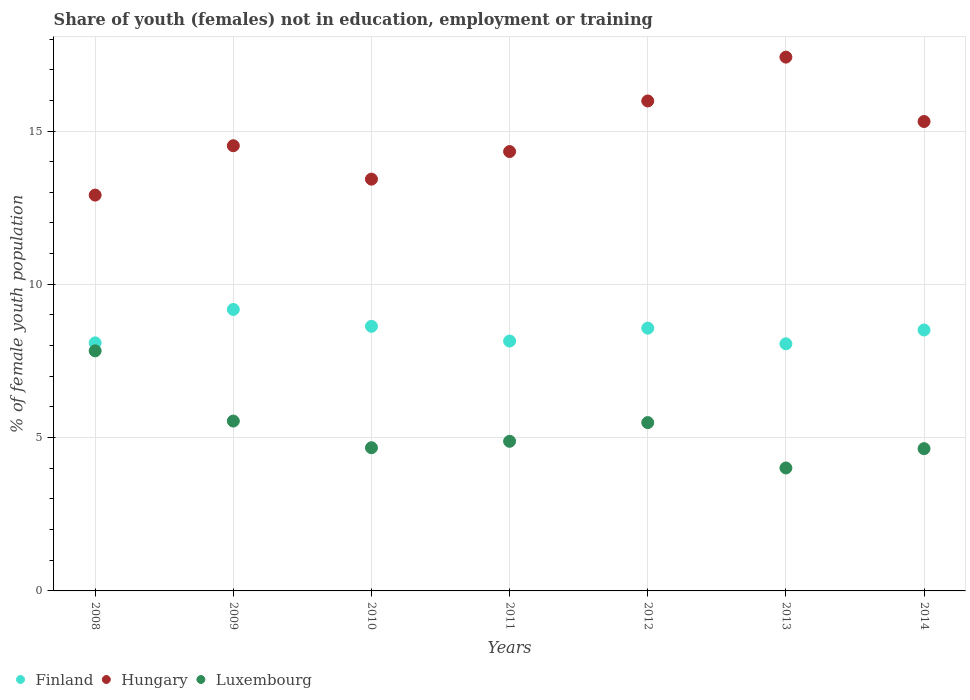How many different coloured dotlines are there?
Give a very brief answer. 3. What is the percentage of unemployed female population in in Finland in 2014?
Give a very brief answer. 8.51. Across all years, what is the maximum percentage of unemployed female population in in Luxembourg?
Your answer should be very brief. 7.83. Across all years, what is the minimum percentage of unemployed female population in in Hungary?
Your answer should be compact. 12.91. What is the total percentage of unemployed female population in in Luxembourg in the graph?
Your answer should be very brief. 37.06. What is the difference between the percentage of unemployed female population in in Luxembourg in 2011 and that in 2014?
Provide a short and direct response. 0.24. What is the difference between the percentage of unemployed female population in in Finland in 2011 and the percentage of unemployed female population in in Luxembourg in 2009?
Ensure brevity in your answer.  2.61. What is the average percentage of unemployed female population in in Hungary per year?
Offer a terse response. 14.84. In the year 2009, what is the difference between the percentage of unemployed female population in in Hungary and percentage of unemployed female population in in Luxembourg?
Keep it short and to the point. 8.98. What is the ratio of the percentage of unemployed female population in in Hungary in 2009 to that in 2013?
Ensure brevity in your answer.  0.83. Is the percentage of unemployed female population in in Finland in 2010 less than that in 2012?
Provide a short and direct response. No. Is the difference between the percentage of unemployed female population in in Hungary in 2010 and 2013 greater than the difference between the percentage of unemployed female population in in Luxembourg in 2010 and 2013?
Keep it short and to the point. No. What is the difference between the highest and the second highest percentage of unemployed female population in in Hungary?
Provide a short and direct response. 1.43. What is the difference between the highest and the lowest percentage of unemployed female population in in Hungary?
Offer a very short reply. 4.5. In how many years, is the percentage of unemployed female population in in Hungary greater than the average percentage of unemployed female population in in Hungary taken over all years?
Provide a succinct answer. 3. Is the sum of the percentage of unemployed female population in in Hungary in 2008 and 2012 greater than the maximum percentage of unemployed female population in in Finland across all years?
Offer a very short reply. Yes. Is it the case that in every year, the sum of the percentage of unemployed female population in in Finland and percentage of unemployed female population in in Luxembourg  is greater than the percentage of unemployed female population in in Hungary?
Offer a very short reply. No. Does the percentage of unemployed female population in in Luxembourg monotonically increase over the years?
Keep it short and to the point. No. Is the percentage of unemployed female population in in Luxembourg strictly less than the percentage of unemployed female population in in Finland over the years?
Your response must be concise. Yes. What is the difference between two consecutive major ticks on the Y-axis?
Provide a short and direct response. 5. Does the graph contain grids?
Give a very brief answer. Yes. Where does the legend appear in the graph?
Offer a terse response. Bottom left. How many legend labels are there?
Keep it short and to the point. 3. How are the legend labels stacked?
Your answer should be very brief. Horizontal. What is the title of the graph?
Offer a terse response. Share of youth (females) not in education, employment or training. What is the label or title of the X-axis?
Ensure brevity in your answer.  Years. What is the label or title of the Y-axis?
Provide a succinct answer. % of female youth population. What is the % of female youth population in Finland in 2008?
Your answer should be compact. 8.09. What is the % of female youth population in Hungary in 2008?
Provide a succinct answer. 12.91. What is the % of female youth population in Luxembourg in 2008?
Give a very brief answer. 7.83. What is the % of female youth population of Finland in 2009?
Keep it short and to the point. 9.18. What is the % of female youth population of Hungary in 2009?
Your response must be concise. 14.52. What is the % of female youth population of Luxembourg in 2009?
Your answer should be compact. 5.54. What is the % of female youth population of Finland in 2010?
Provide a short and direct response. 8.63. What is the % of female youth population in Hungary in 2010?
Make the answer very short. 13.43. What is the % of female youth population of Luxembourg in 2010?
Provide a succinct answer. 4.67. What is the % of female youth population of Finland in 2011?
Provide a short and direct response. 8.15. What is the % of female youth population of Hungary in 2011?
Provide a succinct answer. 14.33. What is the % of female youth population in Luxembourg in 2011?
Provide a succinct answer. 4.88. What is the % of female youth population of Finland in 2012?
Offer a very short reply. 8.57. What is the % of female youth population of Hungary in 2012?
Keep it short and to the point. 15.98. What is the % of female youth population in Luxembourg in 2012?
Provide a short and direct response. 5.49. What is the % of female youth population of Finland in 2013?
Make the answer very short. 8.06. What is the % of female youth population of Hungary in 2013?
Make the answer very short. 17.41. What is the % of female youth population of Luxembourg in 2013?
Ensure brevity in your answer.  4.01. What is the % of female youth population in Finland in 2014?
Your response must be concise. 8.51. What is the % of female youth population of Hungary in 2014?
Provide a succinct answer. 15.31. What is the % of female youth population in Luxembourg in 2014?
Make the answer very short. 4.64. Across all years, what is the maximum % of female youth population in Finland?
Ensure brevity in your answer.  9.18. Across all years, what is the maximum % of female youth population in Hungary?
Ensure brevity in your answer.  17.41. Across all years, what is the maximum % of female youth population of Luxembourg?
Make the answer very short. 7.83. Across all years, what is the minimum % of female youth population in Finland?
Provide a short and direct response. 8.06. Across all years, what is the minimum % of female youth population of Hungary?
Keep it short and to the point. 12.91. Across all years, what is the minimum % of female youth population in Luxembourg?
Your response must be concise. 4.01. What is the total % of female youth population in Finland in the graph?
Offer a terse response. 59.19. What is the total % of female youth population of Hungary in the graph?
Make the answer very short. 103.89. What is the total % of female youth population of Luxembourg in the graph?
Make the answer very short. 37.06. What is the difference between the % of female youth population in Finland in 2008 and that in 2009?
Provide a short and direct response. -1.09. What is the difference between the % of female youth population of Hungary in 2008 and that in 2009?
Your response must be concise. -1.61. What is the difference between the % of female youth population in Luxembourg in 2008 and that in 2009?
Keep it short and to the point. 2.29. What is the difference between the % of female youth population of Finland in 2008 and that in 2010?
Provide a succinct answer. -0.54. What is the difference between the % of female youth population in Hungary in 2008 and that in 2010?
Your response must be concise. -0.52. What is the difference between the % of female youth population of Luxembourg in 2008 and that in 2010?
Offer a terse response. 3.16. What is the difference between the % of female youth population of Finland in 2008 and that in 2011?
Keep it short and to the point. -0.06. What is the difference between the % of female youth population in Hungary in 2008 and that in 2011?
Provide a short and direct response. -1.42. What is the difference between the % of female youth population in Luxembourg in 2008 and that in 2011?
Ensure brevity in your answer.  2.95. What is the difference between the % of female youth population of Finland in 2008 and that in 2012?
Keep it short and to the point. -0.48. What is the difference between the % of female youth population in Hungary in 2008 and that in 2012?
Provide a succinct answer. -3.07. What is the difference between the % of female youth population in Luxembourg in 2008 and that in 2012?
Provide a succinct answer. 2.34. What is the difference between the % of female youth population in Luxembourg in 2008 and that in 2013?
Offer a very short reply. 3.82. What is the difference between the % of female youth population of Finland in 2008 and that in 2014?
Offer a very short reply. -0.42. What is the difference between the % of female youth population in Luxembourg in 2008 and that in 2014?
Provide a short and direct response. 3.19. What is the difference between the % of female youth population of Finland in 2009 and that in 2010?
Ensure brevity in your answer.  0.55. What is the difference between the % of female youth population of Hungary in 2009 and that in 2010?
Your answer should be very brief. 1.09. What is the difference between the % of female youth population of Luxembourg in 2009 and that in 2010?
Make the answer very short. 0.87. What is the difference between the % of female youth population in Finland in 2009 and that in 2011?
Provide a succinct answer. 1.03. What is the difference between the % of female youth population of Hungary in 2009 and that in 2011?
Keep it short and to the point. 0.19. What is the difference between the % of female youth population of Luxembourg in 2009 and that in 2011?
Ensure brevity in your answer.  0.66. What is the difference between the % of female youth population of Finland in 2009 and that in 2012?
Your answer should be very brief. 0.61. What is the difference between the % of female youth population of Hungary in 2009 and that in 2012?
Your answer should be very brief. -1.46. What is the difference between the % of female youth population in Finland in 2009 and that in 2013?
Offer a terse response. 1.12. What is the difference between the % of female youth population in Hungary in 2009 and that in 2013?
Your response must be concise. -2.89. What is the difference between the % of female youth population of Luxembourg in 2009 and that in 2013?
Keep it short and to the point. 1.53. What is the difference between the % of female youth population of Finland in 2009 and that in 2014?
Your response must be concise. 0.67. What is the difference between the % of female youth population of Hungary in 2009 and that in 2014?
Keep it short and to the point. -0.79. What is the difference between the % of female youth population of Finland in 2010 and that in 2011?
Make the answer very short. 0.48. What is the difference between the % of female youth population in Luxembourg in 2010 and that in 2011?
Offer a very short reply. -0.21. What is the difference between the % of female youth population of Finland in 2010 and that in 2012?
Your answer should be compact. 0.06. What is the difference between the % of female youth population in Hungary in 2010 and that in 2012?
Give a very brief answer. -2.55. What is the difference between the % of female youth population of Luxembourg in 2010 and that in 2012?
Offer a very short reply. -0.82. What is the difference between the % of female youth population of Finland in 2010 and that in 2013?
Provide a succinct answer. 0.57. What is the difference between the % of female youth population of Hungary in 2010 and that in 2013?
Your answer should be compact. -3.98. What is the difference between the % of female youth population in Luxembourg in 2010 and that in 2013?
Your response must be concise. 0.66. What is the difference between the % of female youth population in Finland in 2010 and that in 2014?
Offer a very short reply. 0.12. What is the difference between the % of female youth population in Hungary in 2010 and that in 2014?
Provide a short and direct response. -1.88. What is the difference between the % of female youth population in Luxembourg in 2010 and that in 2014?
Offer a very short reply. 0.03. What is the difference between the % of female youth population of Finland in 2011 and that in 2012?
Your response must be concise. -0.42. What is the difference between the % of female youth population of Hungary in 2011 and that in 2012?
Offer a very short reply. -1.65. What is the difference between the % of female youth population of Luxembourg in 2011 and that in 2012?
Make the answer very short. -0.61. What is the difference between the % of female youth population of Finland in 2011 and that in 2013?
Offer a terse response. 0.09. What is the difference between the % of female youth population in Hungary in 2011 and that in 2013?
Offer a terse response. -3.08. What is the difference between the % of female youth population in Luxembourg in 2011 and that in 2013?
Give a very brief answer. 0.87. What is the difference between the % of female youth population in Finland in 2011 and that in 2014?
Ensure brevity in your answer.  -0.36. What is the difference between the % of female youth population in Hungary in 2011 and that in 2014?
Provide a short and direct response. -0.98. What is the difference between the % of female youth population in Luxembourg in 2011 and that in 2014?
Make the answer very short. 0.24. What is the difference between the % of female youth population of Finland in 2012 and that in 2013?
Offer a terse response. 0.51. What is the difference between the % of female youth population in Hungary in 2012 and that in 2013?
Offer a very short reply. -1.43. What is the difference between the % of female youth population of Luxembourg in 2012 and that in 2013?
Provide a succinct answer. 1.48. What is the difference between the % of female youth population in Finland in 2012 and that in 2014?
Your response must be concise. 0.06. What is the difference between the % of female youth population of Hungary in 2012 and that in 2014?
Your answer should be very brief. 0.67. What is the difference between the % of female youth population in Finland in 2013 and that in 2014?
Your response must be concise. -0.45. What is the difference between the % of female youth population in Hungary in 2013 and that in 2014?
Provide a succinct answer. 2.1. What is the difference between the % of female youth population in Luxembourg in 2013 and that in 2014?
Make the answer very short. -0.63. What is the difference between the % of female youth population in Finland in 2008 and the % of female youth population in Hungary in 2009?
Provide a short and direct response. -6.43. What is the difference between the % of female youth population of Finland in 2008 and the % of female youth population of Luxembourg in 2009?
Offer a very short reply. 2.55. What is the difference between the % of female youth population of Hungary in 2008 and the % of female youth population of Luxembourg in 2009?
Provide a short and direct response. 7.37. What is the difference between the % of female youth population in Finland in 2008 and the % of female youth population in Hungary in 2010?
Make the answer very short. -5.34. What is the difference between the % of female youth population of Finland in 2008 and the % of female youth population of Luxembourg in 2010?
Make the answer very short. 3.42. What is the difference between the % of female youth population in Hungary in 2008 and the % of female youth population in Luxembourg in 2010?
Give a very brief answer. 8.24. What is the difference between the % of female youth population of Finland in 2008 and the % of female youth population of Hungary in 2011?
Provide a succinct answer. -6.24. What is the difference between the % of female youth population of Finland in 2008 and the % of female youth population of Luxembourg in 2011?
Your answer should be compact. 3.21. What is the difference between the % of female youth population of Hungary in 2008 and the % of female youth population of Luxembourg in 2011?
Offer a very short reply. 8.03. What is the difference between the % of female youth population in Finland in 2008 and the % of female youth population in Hungary in 2012?
Offer a terse response. -7.89. What is the difference between the % of female youth population of Hungary in 2008 and the % of female youth population of Luxembourg in 2012?
Your response must be concise. 7.42. What is the difference between the % of female youth population in Finland in 2008 and the % of female youth population in Hungary in 2013?
Your answer should be very brief. -9.32. What is the difference between the % of female youth population of Finland in 2008 and the % of female youth population of Luxembourg in 2013?
Provide a succinct answer. 4.08. What is the difference between the % of female youth population in Finland in 2008 and the % of female youth population in Hungary in 2014?
Provide a succinct answer. -7.22. What is the difference between the % of female youth population in Finland in 2008 and the % of female youth population in Luxembourg in 2014?
Keep it short and to the point. 3.45. What is the difference between the % of female youth population in Hungary in 2008 and the % of female youth population in Luxembourg in 2014?
Give a very brief answer. 8.27. What is the difference between the % of female youth population of Finland in 2009 and the % of female youth population of Hungary in 2010?
Make the answer very short. -4.25. What is the difference between the % of female youth population of Finland in 2009 and the % of female youth population of Luxembourg in 2010?
Offer a very short reply. 4.51. What is the difference between the % of female youth population of Hungary in 2009 and the % of female youth population of Luxembourg in 2010?
Ensure brevity in your answer.  9.85. What is the difference between the % of female youth population of Finland in 2009 and the % of female youth population of Hungary in 2011?
Your answer should be very brief. -5.15. What is the difference between the % of female youth population in Finland in 2009 and the % of female youth population in Luxembourg in 2011?
Keep it short and to the point. 4.3. What is the difference between the % of female youth population of Hungary in 2009 and the % of female youth population of Luxembourg in 2011?
Provide a succinct answer. 9.64. What is the difference between the % of female youth population of Finland in 2009 and the % of female youth population of Hungary in 2012?
Provide a short and direct response. -6.8. What is the difference between the % of female youth population in Finland in 2009 and the % of female youth population in Luxembourg in 2012?
Your answer should be compact. 3.69. What is the difference between the % of female youth population of Hungary in 2009 and the % of female youth population of Luxembourg in 2012?
Offer a terse response. 9.03. What is the difference between the % of female youth population in Finland in 2009 and the % of female youth population in Hungary in 2013?
Your answer should be very brief. -8.23. What is the difference between the % of female youth population of Finland in 2009 and the % of female youth population of Luxembourg in 2013?
Your answer should be very brief. 5.17. What is the difference between the % of female youth population in Hungary in 2009 and the % of female youth population in Luxembourg in 2013?
Offer a terse response. 10.51. What is the difference between the % of female youth population in Finland in 2009 and the % of female youth population in Hungary in 2014?
Your response must be concise. -6.13. What is the difference between the % of female youth population of Finland in 2009 and the % of female youth population of Luxembourg in 2014?
Offer a very short reply. 4.54. What is the difference between the % of female youth population in Hungary in 2009 and the % of female youth population in Luxembourg in 2014?
Make the answer very short. 9.88. What is the difference between the % of female youth population of Finland in 2010 and the % of female youth population of Hungary in 2011?
Give a very brief answer. -5.7. What is the difference between the % of female youth population in Finland in 2010 and the % of female youth population in Luxembourg in 2011?
Offer a very short reply. 3.75. What is the difference between the % of female youth population in Hungary in 2010 and the % of female youth population in Luxembourg in 2011?
Ensure brevity in your answer.  8.55. What is the difference between the % of female youth population in Finland in 2010 and the % of female youth population in Hungary in 2012?
Keep it short and to the point. -7.35. What is the difference between the % of female youth population of Finland in 2010 and the % of female youth population of Luxembourg in 2012?
Your response must be concise. 3.14. What is the difference between the % of female youth population in Hungary in 2010 and the % of female youth population in Luxembourg in 2012?
Your answer should be compact. 7.94. What is the difference between the % of female youth population of Finland in 2010 and the % of female youth population of Hungary in 2013?
Your response must be concise. -8.78. What is the difference between the % of female youth population in Finland in 2010 and the % of female youth population in Luxembourg in 2013?
Give a very brief answer. 4.62. What is the difference between the % of female youth population in Hungary in 2010 and the % of female youth population in Luxembourg in 2013?
Provide a short and direct response. 9.42. What is the difference between the % of female youth population in Finland in 2010 and the % of female youth population in Hungary in 2014?
Your answer should be very brief. -6.68. What is the difference between the % of female youth population in Finland in 2010 and the % of female youth population in Luxembourg in 2014?
Offer a very short reply. 3.99. What is the difference between the % of female youth population in Hungary in 2010 and the % of female youth population in Luxembourg in 2014?
Provide a succinct answer. 8.79. What is the difference between the % of female youth population of Finland in 2011 and the % of female youth population of Hungary in 2012?
Give a very brief answer. -7.83. What is the difference between the % of female youth population of Finland in 2011 and the % of female youth population of Luxembourg in 2012?
Provide a short and direct response. 2.66. What is the difference between the % of female youth population of Hungary in 2011 and the % of female youth population of Luxembourg in 2012?
Give a very brief answer. 8.84. What is the difference between the % of female youth population in Finland in 2011 and the % of female youth population in Hungary in 2013?
Provide a succinct answer. -9.26. What is the difference between the % of female youth population in Finland in 2011 and the % of female youth population in Luxembourg in 2013?
Your answer should be compact. 4.14. What is the difference between the % of female youth population of Hungary in 2011 and the % of female youth population of Luxembourg in 2013?
Ensure brevity in your answer.  10.32. What is the difference between the % of female youth population of Finland in 2011 and the % of female youth population of Hungary in 2014?
Offer a terse response. -7.16. What is the difference between the % of female youth population of Finland in 2011 and the % of female youth population of Luxembourg in 2014?
Give a very brief answer. 3.51. What is the difference between the % of female youth population in Hungary in 2011 and the % of female youth population in Luxembourg in 2014?
Your response must be concise. 9.69. What is the difference between the % of female youth population of Finland in 2012 and the % of female youth population of Hungary in 2013?
Give a very brief answer. -8.84. What is the difference between the % of female youth population in Finland in 2012 and the % of female youth population in Luxembourg in 2013?
Offer a very short reply. 4.56. What is the difference between the % of female youth population in Hungary in 2012 and the % of female youth population in Luxembourg in 2013?
Your response must be concise. 11.97. What is the difference between the % of female youth population in Finland in 2012 and the % of female youth population in Hungary in 2014?
Offer a very short reply. -6.74. What is the difference between the % of female youth population of Finland in 2012 and the % of female youth population of Luxembourg in 2014?
Make the answer very short. 3.93. What is the difference between the % of female youth population in Hungary in 2012 and the % of female youth population in Luxembourg in 2014?
Ensure brevity in your answer.  11.34. What is the difference between the % of female youth population of Finland in 2013 and the % of female youth population of Hungary in 2014?
Your response must be concise. -7.25. What is the difference between the % of female youth population of Finland in 2013 and the % of female youth population of Luxembourg in 2014?
Your response must be concise. 3.42. What is the difference between the % of female youth population of Hungary in 2013 and the % of female youth population of Luxembourg in 2014?
Your answer should be very brief. 12.77. What is the average % of female youth population in Finland per year?
Make the answer very short. 8.46. What is the average % of female youth population of Hungary per year?
Your answer should be compact. 14.84. What is the average % of female youth population of Luxembourg per year?
Ensure brevity in your answer.  5.29. In the year 2008, what is the difference between the % of female youth population in Finland and % of female youth population in Hungary?
Ensure brevity in your answer.  -4.82. In the year 2008, what is the difference between the % of female youth population in Finland and % of female youth population in Luxembourg?
Your answer should be very brief. 0.26. In the year 2008, what is the difference between the % of female youth population in Hungary and % of female youth population in Luxembourg?
Provide a short and direct response. 5.08. In the year 2009, what is the difference between the % of female youth population of Finland and % of female youth population of Hungary?
Your answer should be very brief. -5.34. In the year 2009, what is the difference between the % of female youth population in Finland and % of female youth population in Luxembourg?
Offer a terse response. 3.64. In the year 2009, what is the difference between the % of female youth population of Hungary and % of female youth population of Luxembourg?
Your answer should be compact. 8.98. In the year 2010, what is the difference between the % of female youth population of Finland and % of female youth population of Luxembourg?
Keep it short and to the point. 3.96. In the year 2010, what is the difference between the % of female youth population of Hungary and % of female youth population of Luxembourg?
Offer a very short reply. 8.76. In the year 2011, what is the difference between the % of female youth population in Finland and % of female youth population in Hungary?
Your answer should be very brief. -6.18. In the year 2011, what is the difference between the % of female youth population of Finland and % of female youth population of Luxembourg?
Offer a very short reply. 3.27. In the year 2011, what is the difference between the % of female youth population of Hungary and % of female youth population of Luxembourg?
Keep it short and to the point. 9.45. In the year 2012, what is the difference between the % of female youth population of Finland and % of female youth population of Hungary?
Provide a succinct answer. -7.41. In the year 2012, what is the difference between the % of female youth population of Finland and % of female youth population of Luxembourg?
Give a very brief answer. 3.08. In the year 2012, what is the difference between the % of female youth population of Hungary and % of female youth population of Luxembourg?
Provide a short and direct response. 10.49. In the year 2013, what is the difference between the % of female youth population in Finland and % of female youth population in Hungary?
Ensure brevity in your answer.  -9.35. In the year 2013, what is the difference between the % of female youth population of Finland and % of female youth population of Luxembourg?
Offer a very short reply. 4.05. In the year 2013, what is the difference between the % of female youth population of Hungary and % of female youth population of Luxembourg?
Your answer should be very brief. 13.4. In the year 2014, what is the difference between the % of female youth population in Finland and % of female youth population in Luxembourg?
Provide a succinct answer. 3.87. In the year 2014, what is the difference between the % of female youth population in Hungary and % of female youth population in Luxembourg?
Provide a succinct answer. 10.67. What is the ratio of the % of female youth population of Finland in 2008 to that in 2009?
Make the answer very short. 0.88. What is the ratio of the % of female youth population of Hungary in 2008 to that in 2009?
Offer a terse response. 0.89. What is the ratio of the % of female youth population in Luxembourg in 2008 to that in 2009?
Ensure brevity in your answer.  1.41. What is the ratio of the % of female youth population of Finland in 2008 to that in 2010?
Your answer should be very brief. 0.94. What is the ratio of the % of female youth population in Hungary in 2008 to that in 2010?
Your answer should be very brief. 0.96. What is the ratio of the % of female youth population of Luxembourg in 2008 to that in 2010?
Your answer should be very brief. 1.68. What is the ratio of the % of female youth population in Finland in 2008 to that in 2011?
Your answer should be very brief. 0.99. What is the ratio of the % of female youth population in Hungary in 2008 to that in 2011?
Provide a short and direct response. 0.9. What is the ratio of the % of female youth population in Luxembourg in 2008 to that in 2011?
Keep it short and to the point. 1.6. What is the ratio of the % of female youth population of Finland in 2008 to that in 2012?
Provide a short and direct response. 0.94. What is the ratio of the % of female youth population of Hungary in 2008 to that in 2012?
Your answer should be compact. 0.81. What is the ratio of the % of female youth population of Luxembourg in 2008 to that in 2012?
Provide a succinct answer. 1.43. What is the ratio of the % of female youth population in Hungary in 2008 to that in 2013?
Provide a succinct answer. 0.74. What is the ratio of the % of female youth population of Luxembourg in 2008 to that in 2013?
Your response must be concise. 1.95. What is the ratio of the % of female youth population of Finland in 2008 to that in 2014?
Ensure brevity in your answer.  0.95. What is the ratio of the % of female youth population of Hungary in 2008 to that in 2014?
Provide a short and direct response. 0.84. What is the ratio of the % of female youth population in Luxembourg in 2008 to that in 2014?
Give a very brief answer. 1.69. What is the ratio of the % of female youth population of Finland in 2009 to that in 2010?
Make the answer very short. 1.06. What is the ratio of the % of female youth population in Hungary in 2009 to that in 2010?
Give a very brief answer. 1.08. What is the ratio of the % of female youth population of Luxembourg in 2009 to that in 2010?
Ensure brevity in your answer.  1.19. What is the ratio of the % of female youth population of Finland in 2009 to that in 2011?
Make the answer very short. 1.13. What is the ratio of the % of female youth population in Hungary in 2009 to that in 2011?
Keep it short and to the point. 1.01. What is the ratio of the % of female youth population of Luxembourg in 2009 to that in 2011?
Provide a short and direct response. 1.14. What is the ratio of the % of female youth population of Finland in 2009 to that in 2012?
Ensure brevity in your answer.  1.07. What is the ratio of the % of female youth population of Hungary in 2009 to that in 2012?
Ensure brevity in your answer.  0.91. What is the ratio of the % of female youth population in Luxembourg in 2009 to that in 2012?
Provide a succinct answer. 1.01. What is the ratio of the % of female youth population of Finland in 2009 to that in 2013?
Your answer should be very brief. 1.14. What is the ratio of the % of female youth population of Hungary in 2009 to that in 2013?
Your response must be concise. 0.83. What is the ratio of the % of female youth population in Luxembourg in 2009 to that in 2013?
Ensure brevity in your answer.  1.38. What is the ratio of the % of female youth population of Finland in 2009 to that in 2014?
Provide a succinct answer. 1.08. What is the ratio of the % of female youth population in Hungary in 2009 to that in 2014?
Your response must be concise. 0.95. What is the ratio of the % of female youth population in Luxembourg in 2009 to that in 2014?
Your answer should be very brief. 1.19. What is the ratio of the % of female youth population in Finland in 2010 to that in 2011?
Offer a very short reply. 1.06. What is the ratio of the % of female youth population of Hungary in 2010 to that in 2011?
Ensure brevity in your answer.  0.94. What is the ratio of the % of female youth population in Luxembourg in 2010 to that in 2011?
Ensure brevity in your answer.  0.96. What is the ratio of the % of female youth population of Hungary in 2010 to that in 2012?
Offer a very short reply. 0.84. What is the ratio of the % of female youth population in Luxembourg in 2010 to that in 2012?
Provide a succinct answer. 0.85. What is the ratio of the % of female youth population in Finland in 2010 to that in 2013?
Provide a succinct answer. 1.07. What is the ratio of the % of female youth population of Hungary in 2010 to that in 2013?
Provide a short and direct response. 0.77. What is the ratio of the % of female youth population in Luxembourg in 2010 to that in 2013?
Ensure brevity in your answer.  1.16. What is the ratio of the % of female youth population in Finland in 2010 to that in 2014?
Ensure brevity in your answer.  1.01. What is the ratio of the % of female youth population in Hungary in 2010 to that in 2014?
Ensure brevity in your answer.  0.88. What is the ratio of the % of female youth population in Luxembourg in 2010 to that in 2014?
Your response must be concise. 1.01. What is the ratio of the % of female youth population of Finland in 2011 to that in 2012?
Offer a terse response. 0.95. What is the ratio of the % of female youth population of Hungary in 2011 to that in 2012?
Provide a succinct answer. 0.9. What is the ratio of the % of female youth population of Luxembourg in 2011 to that in 2012?
Provide a short and direct response. 0.89. What is the ratio of the % of female youth population of Finland in 2011 to that in 2013?
Offer a very short reply. 1.01. What is the ratio of the % of female youth population of Hungary in 2011 to that in 2013?
Provide a succinct answer. 0.82. What is the ratio of the % of female youth population of Luxembourg in 2011 to that in 2013?
Provide a succinct answer. 1.22. What is the ratio of the % of female youth population of Finland in 2011 to that in 2014?
Your answer should be very brief. 0.96. What is the ratio of the % of female youth population in Hungary in 2011 to that in 2014?
Keep it short and to the point. 0.94. What is the ratio of the % of female youth population in Luxembourg in 2011 to that in 2014?
Provide a succinct answer. 1.05. What is the ratio of the % of female youth population in Finland in 2012 to that in 2013?
Your answer should be compact. 1.06. What is the ratio of the % of female youth population in Hungary in 2012 to that in 2013?
Ensure brevity in your answer.  0.92. What is the ratio of the % of female youth population in Luxembourg in 2012 to that in 2013?
Your answer should be compact. 1.37. What is the ratio of the % of female youth population of Finland in 2012 to that in 2014?
Keep it short and to the point. 1.01. What is the ratio of the % of female youth population in Hungary in 2012 to that in 2014?
Provide a succinct answer. 1.04. What is the ratio of the % of female youth population in Luxembourg in 2012 to that in 2014?
Offer a terse response. 1.18. What is the ratio of the % of female youth population in Finland in 2013 to that in 2014?
Keep it short and to the point. 0.95. What is the ratio of the % of female youth population of Hungary in 2013 to that in 2014?
Keep it short and to the point. 1.14. What is the ratio of the % of female youth population of Luxembourg in 2013 to that in 2014?
Provide a short and direct response. 0.86. What is the difference between the highest and the second highest % of female youth population of Finland?
Keep it short and to the point. 0.55. What is the difference between the highest and the second highest % of female youth population of Hungary?
Keep it short and to the point. 1.43. What is the difference between the highest and the second highest % of female youth population in Luxembourg?
Your answer should be very brief. 2.29. What is the difference between the highest and the lowest % of female youth population of Finland?
Provide a succinct answer. 1.12. What is the difference between the highest and the lowest % of female youth population of Hungary?
Provide a succinct answer. 4.5. What is the difference between the highest and the lowest % of female youth population of Luxembourg?
Ensure brevity in your answer.  3.82. 